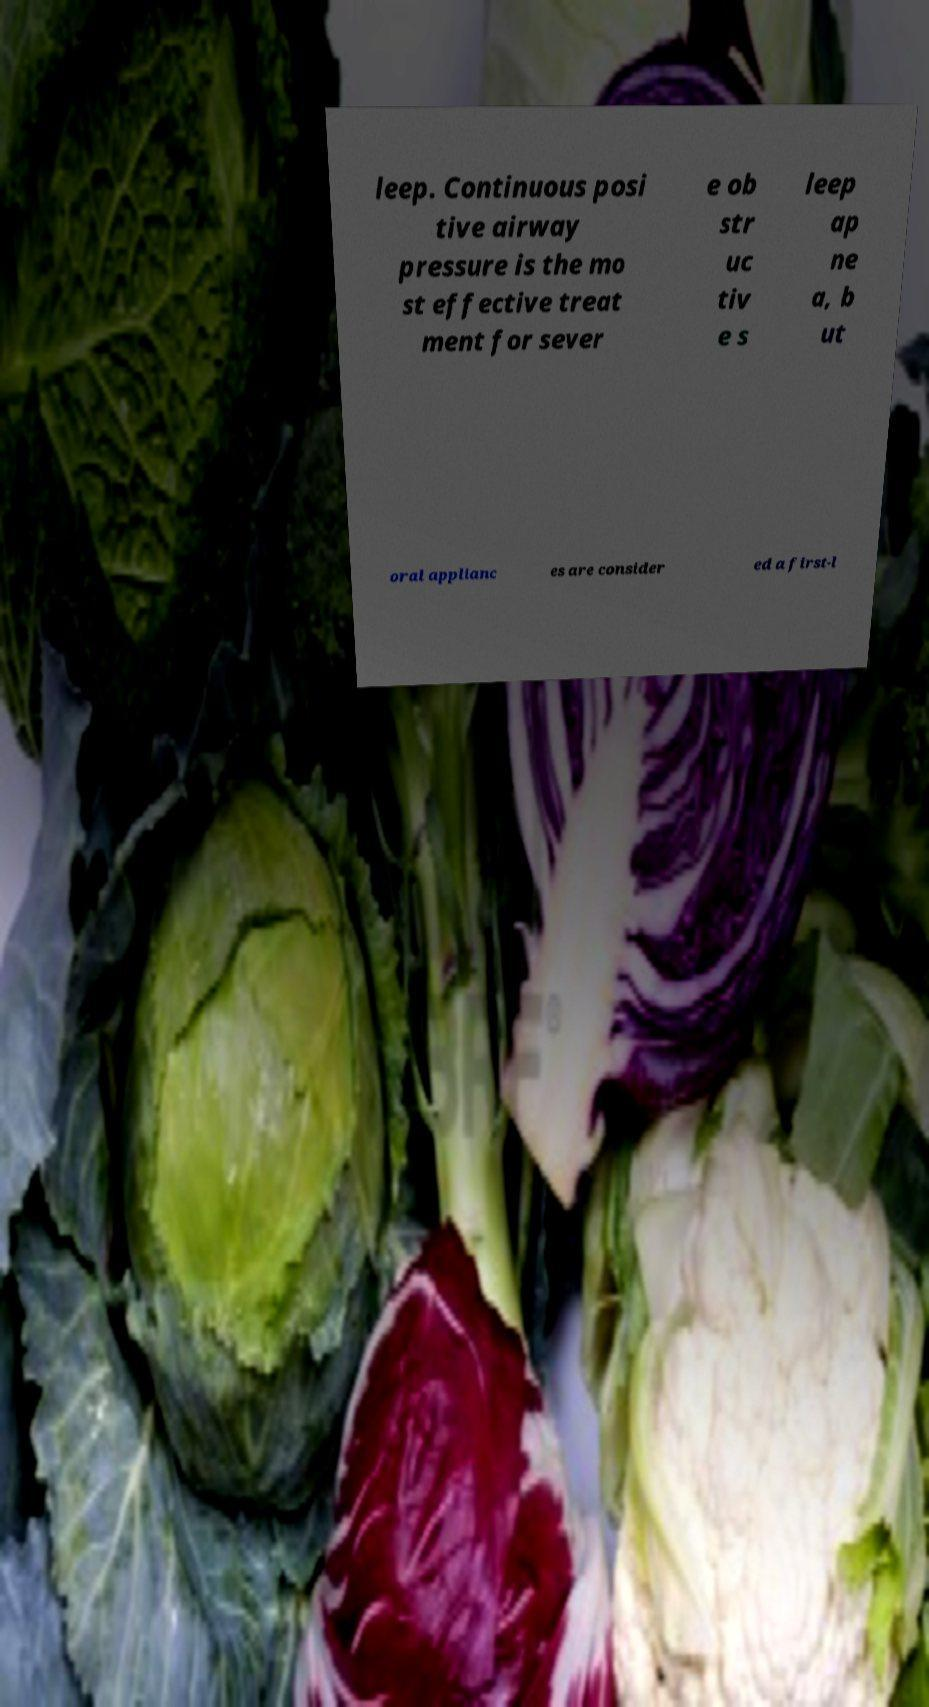For documentation purposes, I need the text within this image transcribed. Could you provide that? leep. Continuous posi tive airway pressure is the mo st effective treat ment for sever e ob str uc tiv e s leep ap ne a, b ut oral applianc es are consider ed a first-l 